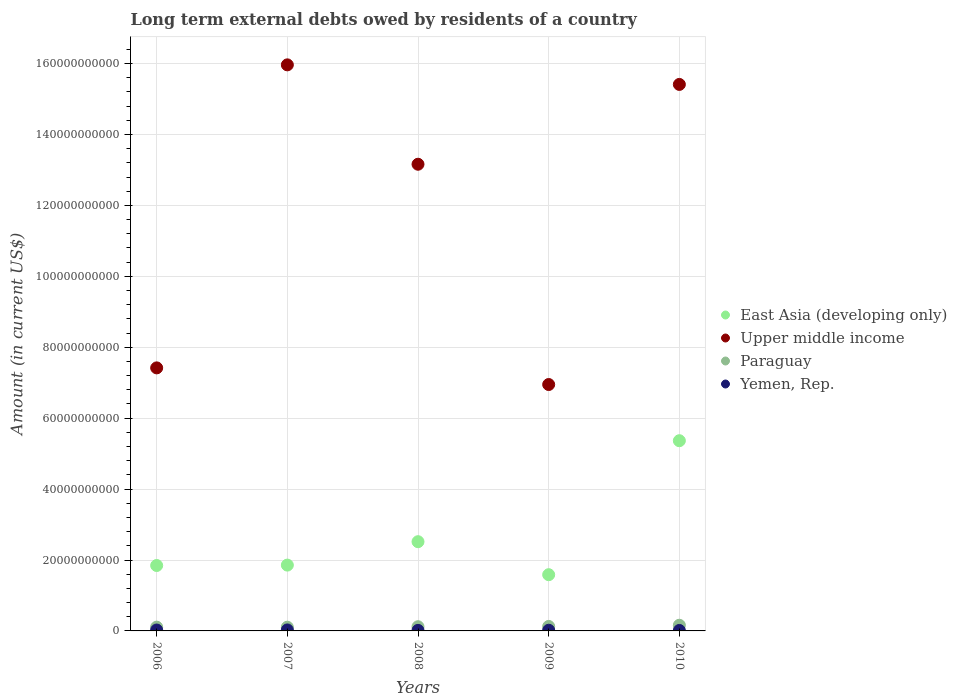Is the number of dotlines equal to the number of legend labels?
Provide a succinct answer. Yes. What is the amount of long-term external debts owed by residents in Upper middle income in 2008?
Keep it short and to the point. 1.32e+11. Across all years, what is the maximum amount of long-term external debts owed by residents in Paraguay?
Your answer should be very brief. 1.60e+09. Across all years, what is the minimum amount of long-term external debts owed by residents in Paraguay?
Offer a terse response. 1.05e+09. In which year was the amount of long-term external debts owed by residents in Upper middle income maximum?
Provide a short and direct response. 2007. In which year was the amount of long-term external debts owed by residents in Yemen, Rep. minimum?
Keep it short and to the point. 2010. What is the total amount of long-term external debts owed by residents in Upper middle income in the graph?
Make the answer very short. 5.89e+11. What is the difference between the amount of long-term external debts owed by residents in East Asia (developing only) in 2006 and that in 2010?
Your response must be concise. -3.52e+1. What is the difference between the amount of long-term external debts owed by residents in East Asia (developing only) in 2008 and the amount of long-term external debts owed by residents in Upper middle income in 2010?
Your answer should be compact. -1.29e+11. What is the average amount of long-term external debts owed by residents in East Asia (developing only) per year?
Keep it short and to the point. 2.63e+1. In the year 2007, what is the difference between the amount of long-term external debts owed by residents in Yemen, Rep. and amount of long-term external debts owed by residents in Paraguay?
Ensure brevity in your answer.  -7.73e+08. What is the ratio of the amount of long-term external debts owed by residents in Yemen, Rep. in 2007 to that in 2009?
Offer a very short reply. 1.44. Is the amount of long-term external debts owed by residents in Yemen, Rep. in 2007 less than that in 2010?
Provide a succinct answer. No. What is the difference between the highest and the second highest amount of long-term external debts owed by residents in Paraguay?
Your answer should be compact. 3.36e+08. What is the difference between the highest and the lowest amount of long-term external debts owed by residents in Upper middle income?
Your response must be concise. 9.01e+1. Is the sum of the amount of long-term external debts owed by residents in Upper middle income in 2006 and 2009 greater than the maximum amount of long-term external debts owed by residents in Paraguay across all years?
Make the answer very short. Yes. Is the amount of long-term external debts owed by residents in Paraguay strictly greater than the amount of long-term external debts owed by residents in Upper middle income over the years?
Offer a very short reply. No. How many years are there in the graph?
Give a very brief answer. 5. Does the graph contain grids?
Keep it short and to the point. Yes. How are the legend labels stacked?
Your response must be concise. Vertical. What is the title of the graph?
Give a very brief answer. Long term external debts owed by residents of a country. What is the label or title of the Y-axis?
Your response must be concise. Amount (in current US$). What is the Amount (in current US$) in East Asia (developing only) in 2006?
Your answer should be very brief. 1.84e+1. What is the Amount (in current US$) of Upper middle income in 2006?
Keep it short and to the point. 7.42e+1. What is the Amount (in current US$) of Paraguay in 2006?
Your response must be concise. 1.06e+09. What is the Amount (in current US$) in Yemen, Rep. in 2006?
Keep it short and to the point. 2.52e+08. What is the Amount (in current US$) of East Asia (developing only) in 2007?
Offer a terse response. 1.86e+1. What is the Amount (in current US$) of Upper middle income in 2007?
Keep it short and to the point. 1.60e+11. What is the Amount (in current US$) of Paraguay in 2007?
Your response must be concise. 1.05e+09. What is the Amount (in current US$) of Yemen, Rep. in 2007?
Ensure brevity in your answer.  2.77e+08. What is the Amount (in current US$) of East Asia (developing only) in 2008?
Provide a short and direct response. 2.52e+1. What is the Amount (in current US$) of Upper middle income in 2008?
Make the answer very short. 1.32e+11. What is the Amount (in current US$) in Paraguay in 2008?
Your response must be concise. 1.18e+09. What is the Amount (in current US$) of Yemen, Rep. in 2008?
Give a very brief answer. 1.51e+08. What is the Amount (in current US$) of East Asia (developing only) in 2009?
Your answer should be compact. 1.59e+1. What is the Amount (in current US$) in Upper middle income in 2009?
Give a very brief answer. 6.95e+1. What is the Amount (in current US$) in Paraguay in 2009?
Offer a very short reply. 1.26e+09. What is the Amount (in current US$) of Yemen, Rep. in 2009?
Your answer should be compact. 1.92e+08. What is the Amount (in current US$) of East Asia (developing only) in 2010?
Your answer should be very brief. 5.36e+1. What is the Amount (in current US$) in Upper middle income in 2010?
Keep it short and to the point. 1.54e+11. What is the Amount (in current US$) in Paraguay in 2010?
Provide a succinct answer. 1.60e+09. What is the Amount (in current US$) in Yemen, Rep. in 2010?
Offer a terse response. 1.32e+08. Across all years, what is the maximum Amount (in current US$) of East Asia (developing only)?
Provide a succinct answer. 5.36e+1. Across all years, what is the maximum Amount (in current US$) of Upper middle income?
Ensure brevity in your answer.  1.60e+11. Across all years, what is the maximum Amount (in current US$) of Paraguay?
Offer a terse response. 1.60e+09. Across all years, what is the maximum Amount (in current US$) in Yemen, Rep.?
Your answer should be compact. 2.77e+08. Across all years, what is the minimum Amount (in current US$) of East Asia (developing only)?
Keep it short and to the point. 1.59e+1. Across all years, what is the minimum Amount (in current US$) in Upper middle income?
Provide a short and direct response. 6.95e+1. Across all years, what is the minimum Amount (in current US$) in Paraguay?
Ensure brevity in your answer.  1.05e+09. Across all years, what is the minimum Amount (in current US$) of Yemen, Rep.?
Give a very brief answer. 1.32e+08. What is the total Amount (in current US$) in East Asia (developing only) in the graph?
Your answer should be compact. 1.32e+11. What is the total Amount (in current US$) of Upper middle income in the graph?
Give a very brief answer. 5.89e+11. What is the total Amount (in current US$) in Paraguay in the graph?
Ensure brevity in your answer.  6.16e+09. What is the total Amount (in current US$) in Yemen, Rep. in the graph?
Ensure brevity in your answer.  1.00e+09. What is the difference between the Amount (in current US$) of East Asia (developing only) in 2006 and that in 2007?
Offer a terse response. -1.14e+08. What is the difference between the Amount (in current US$) in Upper middle income in 2006 and that in 2007?
Make the answer very short. -8.55e+1. What is the difference between the Amount (in current US$) in Paraguay in 2006 and that in 2007?
Keep it short and to the point. 1.30e+07. What is the difference between the Amount (in current US$) of Yemen, Rep. in 2006 and that in 2007?
Ensure brevity in your answer.  -2.52e+07. What is the difference between the Amount (in current US$) of East Asia (developing only) in 2006 and that in 2008?
Provide a succinct answer. -6.72e+09. What is the difference between the Amount (in current US$) of Upper middle income in 2006 and that in 2008?
Your answer should be very brief. -5.74e+1. What is the difference between the Amount (in current US$) in Paraguay in 2006 and that in 2008?
Your response must be concise. -1.21e+08. What is the difference between the Amount (in current US$) in Yemen, Rep. in 2006 and that in 2008?
Give a very brief answer. 1.01e+08. What is the difference between the Amount (in current US$) in East Asia (developing only) in 2006 and that in 2009?
Make the answer very short. 2.59e+09. What is the difference between the Amount (in current US$) of Upper middle income in 2006 and that in 2009?
Offer a terse response. 4.69e+09. What is the difference between the Amount (in current US$) of Paraguay in 2006 and that in 2009?
Your answer should be compact. -1.99e+08. What is the difference between the Amount (in current US$) of Yemen, Rep. in 2006 and that in 2009?
Offer a terse response. 6.00e+07. What is the difference between the Amount (in current US$) in East Asia (developing only) in 2006 and that in 2010?
Your answer should be compact. -3.52e+1. What is the difference between the Amount (in current US$) in Upper middle income in 2006 and that in 2010?
Your answer should be compact. -7.99e+1. What is the difference between the Amount (in current US$) of Paraguay in 2006 and that in 2010?
Your response must be concise. -5.36e+08. What is the difference between the Amount (in current US$) in Yemen, Rep. in 2006 and that in 2010?
Provide a succinct answer. 1.19e+08. What is the difference between the Amount (in current US$) in East Asia (developing only) in 2007 and that in 2008?
Give a very brief answer. -6.60e+09. What is the difference between the Amount (in current US$) in Upper middle income in 2007 and that in 2008?
Offer a very short reply. 2.80e+1. What is the difference between the Amount (in current US$) in Paraguay in 2007 and that in 2008?
Offer a terse response. -1.34e+08. What is the difference between the Amount (in current US$) in Yemen, Rep. in 2007 and that in 2008?
Your answer should be compact. 1.26e+08. What is the difference between the Amount (in current US$) of East Asia (developing only) in 2007 and that in 2009?
Make the answer very short. 2.71e+09. What is the difference between the Amount (in current US$) in Upper middle income in 2007 and that in 2009?
Offer a very short reply. 9.01e+1. What is the difference between the Amount (in current US$) of Paraguay in 2007 and that in 2009?
Your answer should be very brief. -2.12e+08. What is the difference between the Amount (in current US$) in Yemen, Rep. in 2007 and that in 2009?
Your answer should be very brief. 8.53e+07. What is the difference between the Amount (in current US$) of East Asia (developing only) in 2007 and that in 2010?
Offer a terse response. -3.51e+1. What is the difference between the Amount (in current US$) in Upper middle income in 2007 and that in 2010?
Your answer should be very brief. 5.52e+09. What is the difference between the Amount (in current US$) of Paraguay in 2007 and that in 2010?
Your response must be concise. -5.49e+08. What is the difference between the Amount (in current US$) of Yemen, Rep. in 2007 and that in 2010?
Make the answer very short. 1.45e+08. What is the difference between the Amount (in current US$) in East Asia (developing only) in 2008 and that in 2009?
Offer a very short reply. 9.31e+09. What is the difference between the Amount (in current US$) of Upper middle income in 2008 and that in 2009?
Keep it short and to the point. 6.21e+1. What is the difference between the Amount (in current US$) in Paraguay in 2008 and that in 2009?
Your answer should be compact. -7.84e+07. What is the difference between the Amount (in current US$) in Yemen, Rep. in 2008 and that in 2009?
Your response must be concise. -4.09e+07. What is the difference between the Amount (in current US$) of East Asia (developing only) in 2008 and that in 2010?
Make the answer very short. -2.85e+1. What is the difference between the Amount (in current US$) of Upper middle income in 2008 and that in 2010?
Your answer should be compact. -2.25e+1. What is the difference between the Amount (in current US$) of Paraguay in 2008 and that in 2010?
Keep it short and to the point. -4.15e+08. What is the difference between the Amount (in current US$) in Yemen, Rep. in 2008 and that in 2010?
Provide a succinct answer. 1.85e+07. What is the difference between the Amount (in current US$) of East Asia (developing only) in 2009 and that in 2010?
Keep it short and to the point. -3.78e+1. What is the difference between the Amount (in current US$) of Upper middle income in 2009 and that in 2010?
Keep it short and to the point. -8.46e+1. What is the difference between the Amount (in current US$) in Paraguay in 2009 and that in 2010?
Provide a short and direct response. -3.36e+08. What is the difference between the Amount (in current US$) in Yemen, Rep. in 2009 and that in 2010?
Ensure brevity in your answer.  5.94e+07. What is the difference between the Amount (in current US$) of East Asia (developing only) in 2006 and the Amount (in current US$) of Upper middle income in 2007?
Ensure brevity in your answer.  -1.41e+11. What is the difference between the Amount (in current US$) of East Asia (developing only) in 2006 and the Amount (in current US$) of Paraguay in 2007?
Your response must be concise. 1.74e+1. What is the difference between the Amount (in current US$) in East Asia (developing only) in 2006 and the Amount (in current US$) in Yemen, Rep. in 2007?
Offer a very short reply. 1.82e+1. What is the difference between the Amount (in current US$) of Upper middle income in 2006 and the Amount (in current US$) of Paraguay in 2007?
Make the answer very short. 7.31e+1. What is the difference between the Amount (in current US$) in Upper middle income in 2006 and the Amount (in current US$) in Yemen, Rep. in 2007?
Make the answer very short. 7.39e+1. What is the difference between the Amount (in current US$) of Paraguay in 2006 and the Amount (in current US$) of Yemen, Rep. in 2007?
Provide a short and direct response. 7.86e+08. What is the difference between the Amount (in current US$) of East Asia (developing only) in 2006 and the Amount (in current US$) of Upper middle income in 2008?
Make the answer very short. -1.13e+11. What is the difference between the Amount (in current US$) in East Asia (developing only) in 2006 and the Amount (in current US$) in Paraguay in 2008?
Make the answer very short. 1.73e+1. What is the difference between the Amount (in current US$) of East Asia (developing only) in 2006 and the Amount (in current US$) of Yemen, Rep. in 2008?
Make the answer very short. 1.83e+1. What is the difference between the Amount (in current US$) in Upper middle income in 2006 and the Amount (in current US$) in Paraguay in 2008?
Offer a terse response. 7.30e+1. What is the difference between the Amount (in current US$) in Upper middle income in 2006 and the Amount (in current US$) in Yemen, Rep. in 2008?
Ensure brevity in your answer.  7.40e+1. What is the difference between the Amount (in current US$) in Paraguay in 2006 and the Amount (in current US$) in Yemen, Rep. in 2008?
Your response must be concise. 9.12e+08. What is the difference between the Amount (in current US$) in East Asia (developing only) in 2006 and the Amount (in current US$) in Upper middle income in 2009?
Give a very brief answer. -5.10e+1. What is the difference between the Amount (in current US$) in East Asia (developing only) in 2006 and the Amount (in current US$) in Paraguay in 2009?
Provide a succinct answer. 1.72e+1. What is the difference between the Amount (in current US$) of East Asia (developing only) in 2006 and the Amount (in current US$) of Yemen, Rep. in 2009?
Give a very brief answer. 1.83e+1. What is the difference between the Amount (in current US$) of Upper middle income in 2006 and the Amount (in current US$) of Paraguay in 2009?
Your answer should be compact. 7.29e+1. What is the difference between the Amount (in current US$) of Upper middle income in 2006 and the Amount (in current US$) of Yemen, Rep. in 2009?
Make the answer very short. 7.40e+1. What is the difference between the Amount (in current US$) of Paraguay in 2006 and the Amount (in current US$) of Yemen, Rep. in 2009?
Give a very brief answer. 8.71e+08. What is the difference between the Amount (in current US$) of East Asia (developing only) in 2006 and the Amount (in current US$) of Upper middle income in 2010?
Keep it short and to the point. -1.36e+11. What is the difference between the Amount (in current US$) of East Asia (developing only) in 2006 and the Amount (in current US$) of Paraguay in 2010?
Keep it short and to the point. 1.68e+1. What is the difference between the Amount (in current US$) of East Asia (developing only) in 2006 and the Amount (in current US$) of Yemen, Rep. in 2010?
Your answer should be compact. 1.83e+1. What is the difference between the Amount (in current US$) in Upper middle income in 2006 and the Amount (in current US$) in Paraguay in 2010?
Your answer should be compact. 7.26e+1. What is the difference between the Amount (in current US$) in Upper middle income in 2006 and the Amount (in current US$) in Yemen, Rep. in 2010?
Offer a very short reply. 7.40e+1. What is the difference between the Amount (in current US$) of Paraguay in 2006 and the Amount (in current US$) of Yemen, Rep. in 2010?
Provide a short and direct response. 9.31e+08. What is the difference between the Amount (in current US$) in East Asia (developing only) in 2007 and the Amount (in current US$) in Upper middle income in 2008?
Offer a terse response. -1.13e+11. What is the difference between the Amount (in current US$) in East Asia (developing only) in 2007 and the Amount (in current US$) in Paraguay in 2008?
Offer a terse response. 1.74e+1. What is the difference between the Amount (in current US$) of East Asia (developing only) in 2007 and the Amount (in current US$) of Yemen, Rep. in 2008?
Offer a terse response. 1.84e+1. What is the difference between the Amount (in current US$) in Upper middle income in 2007 and the Amount (in current US$) in Paraguay in 2008?
Give a very brief answer. 1.58e+11. What is the difference between the Amount (in current US$) of Upper middle income in 2007 and the Amount (in current US$) of Yemen, Rep. in 2008?
Ensure brevity in your answer.  1.59e+11. What is the difference between the Amount (in current US$) of Paraguay in 2007 and the Amount (in current US$) of Yemen, Rep. in 2008?
Offer a terse response. 8.99e+08. What is the difference between the Amount (in current US$) in East Asia (developing only) in 2007 and the Amount (in current US$) in Upper middle income in 2009?
Keep it short and to the point. -5.09e+1. What is the difference between the Amount (in current US$) in East Asia (developing only) in 2007 and the Amount (in current US$) in Paraguay in 2009?
Give a very brief answer. 1.73e+1. What is the difference between the Amount (in current US$) of East Asia (developing only) in 2007 and the Amount (in current US$) of Yemen, Rep. in 2009?
Give a very brief answer. 1.84e+1. What is the difference between the Amount (in current US$) of Upper middle income in 2007 and the Amount (in current US$) of Paraguay in 2009?
Offer a very short reply. 1.58e+11. What is the difference between the Amount (in current US$) in Upper middle income in 2007 and the Amount (in current US$) in Yemen, Rep. in 2009?
Your answer should be very brief. 1.59e+11. What is the difference between the Amount (in current US$) in Paraguay in 2007 and the Amount (in current US$) in Yemen, Rep. in 2009?
Your answer should be compact. 8.58e+08. What is the difference between the Amount (in current US$) of East Asia (developing only) in 2007 and the Amount (in current US$) of Upper middle income in 2010?
Your answer should be compact. -1.36e+11. What is the difference between the Amount (in current US$) in East Asia (developing only) in 2007 and the Amount (in current US$) in Paraguay in 2010?
Keep it short and to the point. 1.70e+1. What is the difference between the Amount (in current US$) of East Asia (developing only) in 2007 and the Amount (in current US$) of Yemen, Rep. in 2010?
Offer a very short reply. 1.84e+1. What is the difference between the Amount (in current US$) of Upper middle income in 2007 and the Amount (in current US$) of Paraguay in 2010?
Offer a very short reply. 1.58e+11. What is the difference between the Amount (in current US$) of Upper middle income in 2007 and the Amount (in current US$) of Yemen, Rep. in 2010?
Provide a short and direct response. 1.60e+11. What is the difference between the Amount (in current US$) of Paraguay in 2007 and the Amount (in current US$) of Yemen, Rep. in 2010?
Provide a succinct answer. 9.18e+08. What is the difference between the Amount (in current US$) of East Asia (developing only) in 2008 and the Amount (in current US$) of Upper middle income in 2009?
Keep it short and to the point. -4.43e+1. What is the difference between the Amount (in current US$) in East Asia (developing only) in 2008 and the Amount (in current US$) in Paraguay in 2009?
Provide a short and direct response. 2.39e+1. What is the difference between the Amount (in current US$) in East Asia (developing only) in 2008 and the Amount (in current US$) in Yemen, Rep. in 2009?
Provide a short and direct response. 2.50e+1. What is the difference between the Amount (in current US$) in Upper middle income in 2008 and the Amount (in current US$) in Paraguay in 2009?
Provide a short and direct response. 1.30e+11. What is the difference between the Amount (in current US$) of Upper middle income in 2008 and the Amount (in current US$) of Yemen, Rep. in 2009?
Ensure brevity in your answer.  1.31e+11. What is the difference between the Amount (in current US$) of Paraguay in 2008 and the Amount (in current US$) of Yemen, Rep. in 2009?
Make the answer very short. 9.92e+08. What is the difference between the Amount (in current US$) of East Asia (developing only) in 2008 and the Amount (in current US$) of Upper middle income in 2010?
Keep it short and to the point. -1.29e+11. What is the difference between the Amount (in current US$) of East Asia (developing only) in 2008 and the Amount (in current US$) of Paraguay in 2010?
Give a very brief answer. 2.36e+1. What is the difference between the Amount (in current US$) of East Asia (developing only) in 2008 and the Amount (in current US$) of Yemen, Rep. in 2010?
Provide a succinct answer. 2.50e+1. What is the difference between the Amount (in current US$) in Upper middle income in 2008 and the Amount (in current US$) in Paraguay in 2010?
Keep it short and to the point. 1.30e+11. What is the difference between the Amount (in current US$) of Upper middle income in 2008 and the Amount (in current US$) of Yemen, Rep. in 2010?
Give a very brief answer. 1.31e+11. What is the difference between the Amount (in current US$) of Paraguay in 2008 and the Amount (in current US$) of Yemen, Rep. in 2010?
Offer a terse response. 1.05e+09. What is the difference between the Amount (in current US$) of East Asia (developing only) in 2009 and the Amount (in current US$) of Upper middle income in 2010?
Your response must be concise. -1.38e+11. What is the difference between the Amount (in current US$) in East Asia (developing only) in 2009 and the Amount (in current US$) in Paraguay in 2010?
Your answer should be very brief. 1.43e+1. What is the difference between the Amount (in current US$) of East Asia (developing only) in 2009 and the Amount (in current US$) of Yemen, Rep. in 2010?
Keep it short and to the point. 1.57e+1. What is the difference between the Amount (in current US$) of Upper middle income in 2009 and the Amount (in current US$) of Paraguay in 2010?
Offer a terse response. 6.79e+1. What is the difference between the Amount (in current US$) in Upper middle income in 2009 and the Amount (in current US$) in Yemen, Rep. in 2010?
Provide a short and direct response. 6.94e+1. What is the difference between the Amount (in current US$) in Paraguay in 2009 and the Amount (in current US$) in Yemen, Rep. in 2010?
Your answer should be compact. 1.13e+09. What is the average Amount (in current US$) of East Asia (developing only) per year?
Keep it short and to the point. 2.63e+1. What is the average Amount (in current US$) in Upper middle income per year?
Your answer should be very brief. 1.18e+11. What is the average Amount (in current US$) in Paraguay per year?
Give a very brief answer. 1.23e+09. What is the average Amount (in current US$) of Yemen, Rep. per year?
Make the answer very short. 2.01e+08. In the year 2006, what is the difference between the Amount (in current US$) of East Asia (developing only) and Amount (in current US$) of Upper middle income?
Your answer should be very brief. -5.57e+1. In the year 2006, what is the difference between the Amount (in current US$) of East Asia (developing only) and Amount (in current US$) of Paraguay?
Provide a short and direct response. 1.74e+1. In the year 2006, what is the difference between the Amount (in current US$) in East Asia (developing only) and Amount (in current US$) in Yemen, Rep.?
Provide a succinct answer. 1.82e+1. In the year 2006, what is the difference between the Amount (in current US$) of Upper middle income and Amount (in current US$) of Paraguay?
Provide a short and direct response. 7.31e+1. In the year 2006, what is the difference between the Amount (in current US$) in Upper middle income and Amount (in current US$) in Yemen, Rep.?
Give a very brief answer. 7.39e+1. In the year 2006, what is the difference between the Amount (in current US$) of Paraguay and Amount (in current US$) of Yemen, Rep.?
Your answer should be very brief. 8.11e+08. In the year 2007, what is the difference between the Amount (in current US$) in East Asia (developing only) and Amount (in current US$) in Upper middle income?
Offer a very short reply. -1.41e+11. In the year 2007, what is the difference between the Amount (in current US$) of East Asia (developing only) and Amount (in current US$) of Paraguay?
Make the answer very short. 1.75e+1. In the year 2007, what is the difference between the Amount (in current US$) of East Asia (developing only) and Amount (in current US$) of Yemen, Rep.?
Give a very brief answer. 1.83e+1. In the year 2007, what is the difference between the Amount (in current US$) in Upper middle income and Amount (in current US$) in Paraguay?
Offer a terse response. 1.59e+11. In the year 2007, what is the difference between the Amount (in current US$) in Upper middle income and Amount (in current US$) in Yemen, Rep.?
Your response must be concise. 1.59e+11. In the year 2007, what is the difference between the Amount (in current US$) of Paraguay and Amount (in current US$) of Yemen, Rep.?
Give a very brief answer. 7.73e+08. In the year 2008, what is the difference between the Amount (in current US$) of East Asia (developing only) and Amount (in current US$) of Upper middle income?
Ensure brevity in your answer.  -1.06e+11. In the year 2008, what is the difference between the Amount (in current US$) in East Asia (developing only) and Amount (in current US$) in Paraguay?
Make the answer very short. 2.40e+1. In the year 2008, what is the difference between the Amount (in current US$) of East Asia (developing only) and Amount (in current US$) of Yemen, Rep.?
Offer a very short reply. 2.50e+1. In the year 2008, what is the difference between the Amount (in current US$) of Upper middle income and Amount (in current US$) of Paraguay?
Provide a short and direct response. 1.30e+11. In the year 2008, what is the difference between the Amount (in current US$) in Upper middle income and Amount (in current US$) in Yemen, Rep.?
Your answer should be very brief. 1.31e+11. In the year 2008, what is the difference between the Amount (in current US$) in Paraguay and Amount (in current US$) in Yemen, Rep.?
Give a very brief answer. 1.03e+09. In the year 2009, what is the difference between the Amount (in current US$) of East Asia (developing only) and Amount (in current US$) of Upper middle income?
Give a very brief answer. -5.36e+1. In the year 2009, what is the difference between the Amount (in current US$) in East Asia (developing only) and Amount (in current US$) in Paraguay?
Make the answer very short. 1.46e+1. In the year 2009, what is the difference between the Amount (in current US$) of East Asia (developing only) and Amount (in current US$) of Yemen, Rep.?
Provide a succinct answer. 1.57e+1. In the year 2009, what is the difference between the Amount (in current US$) in Upper middle income and Amount (in current US$) in Paraguay?
Provide a short and direct response. 6.82e+1. In the year 2009, what is the difference between the Amount (in current US$) of Upper middle income and Amount (in current US$) of Yemen, Rep.?
Keep it short and to the point. 6.93e+1. In the year 2009, what is the difference between the Amount (in current US$) in Paraguay and Amount (in current US$) in Yemen, Rep.?
Make the answer very short. 1.07e+09. In the year 2010, what is the difference between the Amount (in current US$) of East Asia (developing only) and Amount (in current US$) of Upper middle income?
Offer a very short reply. -1.00e+11. In the year 2010, what is the difference between the Amount (in current US$) of East Asia (developing only) and Amount (in current US$) of Paraguay?
Your answer should be compact. 5.20e+1. In the year 2010, what is the difference between the Amount (in current US$) of East Asia (developing only) and Amount (in current US$) of Yemen, Rep.?
Provide a short and direct response. 5.35e+1. In the year 2010, what is the difference between the Amount (in current US$) in Upper middle income and Amount (in current US$) in Paraguay?
Make the answer very short. 1.53e+11. In the year 2010, what is the difference between the Amount (in current US$) of Upper middle income and Amount (in current US$) of Yemen, Rep.?
Your answer should be compact. 1.54e+11. In the year 2010, what is the difference between the Amount (in current US$) of Paraguay and Amount (in current US$) of Yemen, Rep.?
Offer a very short reply. 1.47e+09. What is the ratio of the Amount (in current US$) of Upper middle income in 2006 to that in 2007?
Provide a short and direct response. 0.46. What is the ratio of the Amount (in current US$) in Paraguay in 2006 to that in 2007?
Keep it short and to the point. 1.01. What is the ratio of the Amount (in current US$) of Yemen, Rep. in 2006 to that in 2007?
Keep it short and to the point. 0.91. What is the ratio of the Amount (in current US$) of East Asia (developing only) in 2006 to that in 2008?
Your answer should be very brief. 0.73. What is the ratio of the Amount (in current US$) in Upper middle income in 2006 to that in 2008?
Ensure brevity in your answer.  0.56. What is the ratio of the Amount (in current US$) of Paraguay in 2006 to that in 2008?
Provide a succinct answer. 0.9. What is the ratio of the Amount (in current US$) of Yemen, Rep. in 2006 to that in 2008?
Make the answer very short. 1.67. What is the ratio of the Amount (in current US$) of East Asia (developing only) in 2006 to that in 2009?
Offer a very short reply. 1.16. What is the ratio of the Amount (in current US$) in Upper middle income in 2006 to that in 2009?
Give a very brief answer. 1.07. What is the ratio of the Amount (in current US$) in Paraguay in 2006 to that in 2009?
Offer a very short reply. 0.84. What is the ratio of the Amount (in current US$) in Yemen, Rep. in 2006 to that in 2009?
Ensure brevity in your answer.  1.31. What is the ratio of the Amount (in current US$) of East Asia (developing only) in 2006 to that in 2010?
Your response must be concise. 0.34. What is the ratio of the Amount (in current US$) in Upper middle income in 2006 to that in 2010?
Provide a succinct answer. 0.48. What is the ratio of the Amount (in current US$) of Paraguay in 2006 to that in 2010?
Make the answer very short. 0.66. What is the ratio of the Amount (in current US$) of Yemen, Rep. in 2006 to that in 2010?
Offer a very short reply. 1.9. What is the ratio of the Amount (in current US$) in East Asia (developing only) in 2007 to that in 2008?
Make the answer very short. 0.74. What is the ratio of the Amount (in current US$) of Upper middle income in 2007 to that in 2008?
Offer a terse response. 1.21. What is the ratio of the Amount (in current US$) of Paraguay in 2007 to that in 2008?
Offer a terse response. 0.89. What is the ratio of the Amount (in current US$) of Yemen, Rep. in 2007 to that in 2008?
Provide a succinct answer. 1.84. What is the ratio of the Amount (in current US$) of East Asia (developing only) in 2007 to that in 2009?
Your answer should be compact. 1.17. What is the ratio of the Amount (in current US$) of Upper middle income in 2007 to that in 2009?
Your response must be concise. 2.3. What is the ratio of the Amount (in current US$) in Paraguay in 2007 to that in 2009?
Provide a short and direct response. 0.83. What is the ratio of the Amount (in current US$) of Yemen, Rep. in 2007 to that in 2009?
Your response must be concise. 1.44. What is the ratio of the Amount (in current US$) in East Asia (developing only) in 2007 to that in 2010?
Your response must be concise. 0.35. What is the ratio of the Amount (in current US$) of Upper middle income in 2007 to that in 2010?
Your answer should be compact. 1.04. What is the ratio of the Amount (in current US$) of Paraguay in 2007 to that in 2010?
Provide a short and direct response. 0.66. What is the ratio of the Amount (in current US$) in Yemen, Rep. in 2007 to that in 2010?
Your answer should be very brief. 2.09. What is the ratio of the Amount (in current US$) of East Asia (developing only) in 2008 to that in 2009?
Provide a short and direct response. 1.59. What is the ratio of the Amount (in current US$) of Upper middle income in 2008 to that in 2009?
Make the answer very short. 1.89. What is the ratio of the Amount (in current US$) of Paraguay in 2008 to that in 2009?
Offer a very short reply. 0.94. What is the ratio of the Amount (in current US$) in Yemen, Rep. in 2008 to that in 2009?
Offer a very short reply. 0.79. What is the ratio of the Amount (in current US$) of East Asia (developing only) in 2008 to that in 2010?
Provide a succinct answer. 0.47. What is the ratio of the Amount (in current US$) of Upper middle income in 2008 to that in 2010?
Provide a short and direct response. 0.85. What is the ratio of the Amount (in current US$) of Paraguay in 2008 to that in 2010?
Ensure brevity in your answer.  0.74. What is the ratio of the Amount (in current US$) of Yemen, Rep. in 2008 to that in 2010?
Your response must be concise. 1.14. What is the ratio of the Amount (in current US$) of East Asia (developing only) in 2009 to that in 2010?
Offer a terse response. 0.3. What is the ratio of the Amount (in current US$) of Upper middle income in 2009 to that in 2010?
Offer a very short reply. 0.45. What is the ratio of the Amount (in current US$) of Paraguay in 2009 to that in 2010?
Keep it short and to the point. 0.79. What is the ratio of the Amount (in current US$) in Yemen, Rep. in 2009 to that in 2010?
Your answer should be very brief. 1.45. What is the difference between the highest and the second highest Amount (in current US$) of East Asia (developing only)?
Ensure brevity in your answer.  2.85e+1. What is the difference between the highest and the second highest Amount (in current US$) of Upper middle income?
Your answer should be compact. 5.52e+09. What is the difference between the highest and the second highest Amount (in current US$) in Paraguay?
Provide a succinct answer. 3.36e+08. What is the difference between the highest and the second highest Amount (in current US$) of Yemen, Rep.?
Your answer should be very brief. 2.52e+07. What is the difference between the highest and the lowest Amount (in current US$) in East Asia (developing only)?
Ensure brevity in your answer.  3.78e+1. What is the difference between the highest and the lowest Amount (in current US$) in Upper middle income?
Give a very brief answer. 9.01e+1. What is the difference between the highest and the lowest Amount (in current US$) in Paraguay?
Ensure brevity in your answer.  5.49e+08. What is the difference between the highest and the lowest Amount (in current US$) of Yemen, Rep.?
Offer a very short reply. 1.45e+08. 